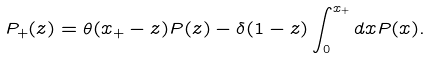Convert formula to latex. <formula><loc_0><loc_0><loc_500><loc_500>P _ { + } ( z ) = \theta ( x _ { + } - z ) P ( z ) - \delta ( 1 - z ) \int _ { 0 } ^ { x _ { + } } d x P ( x ) .</formula> 